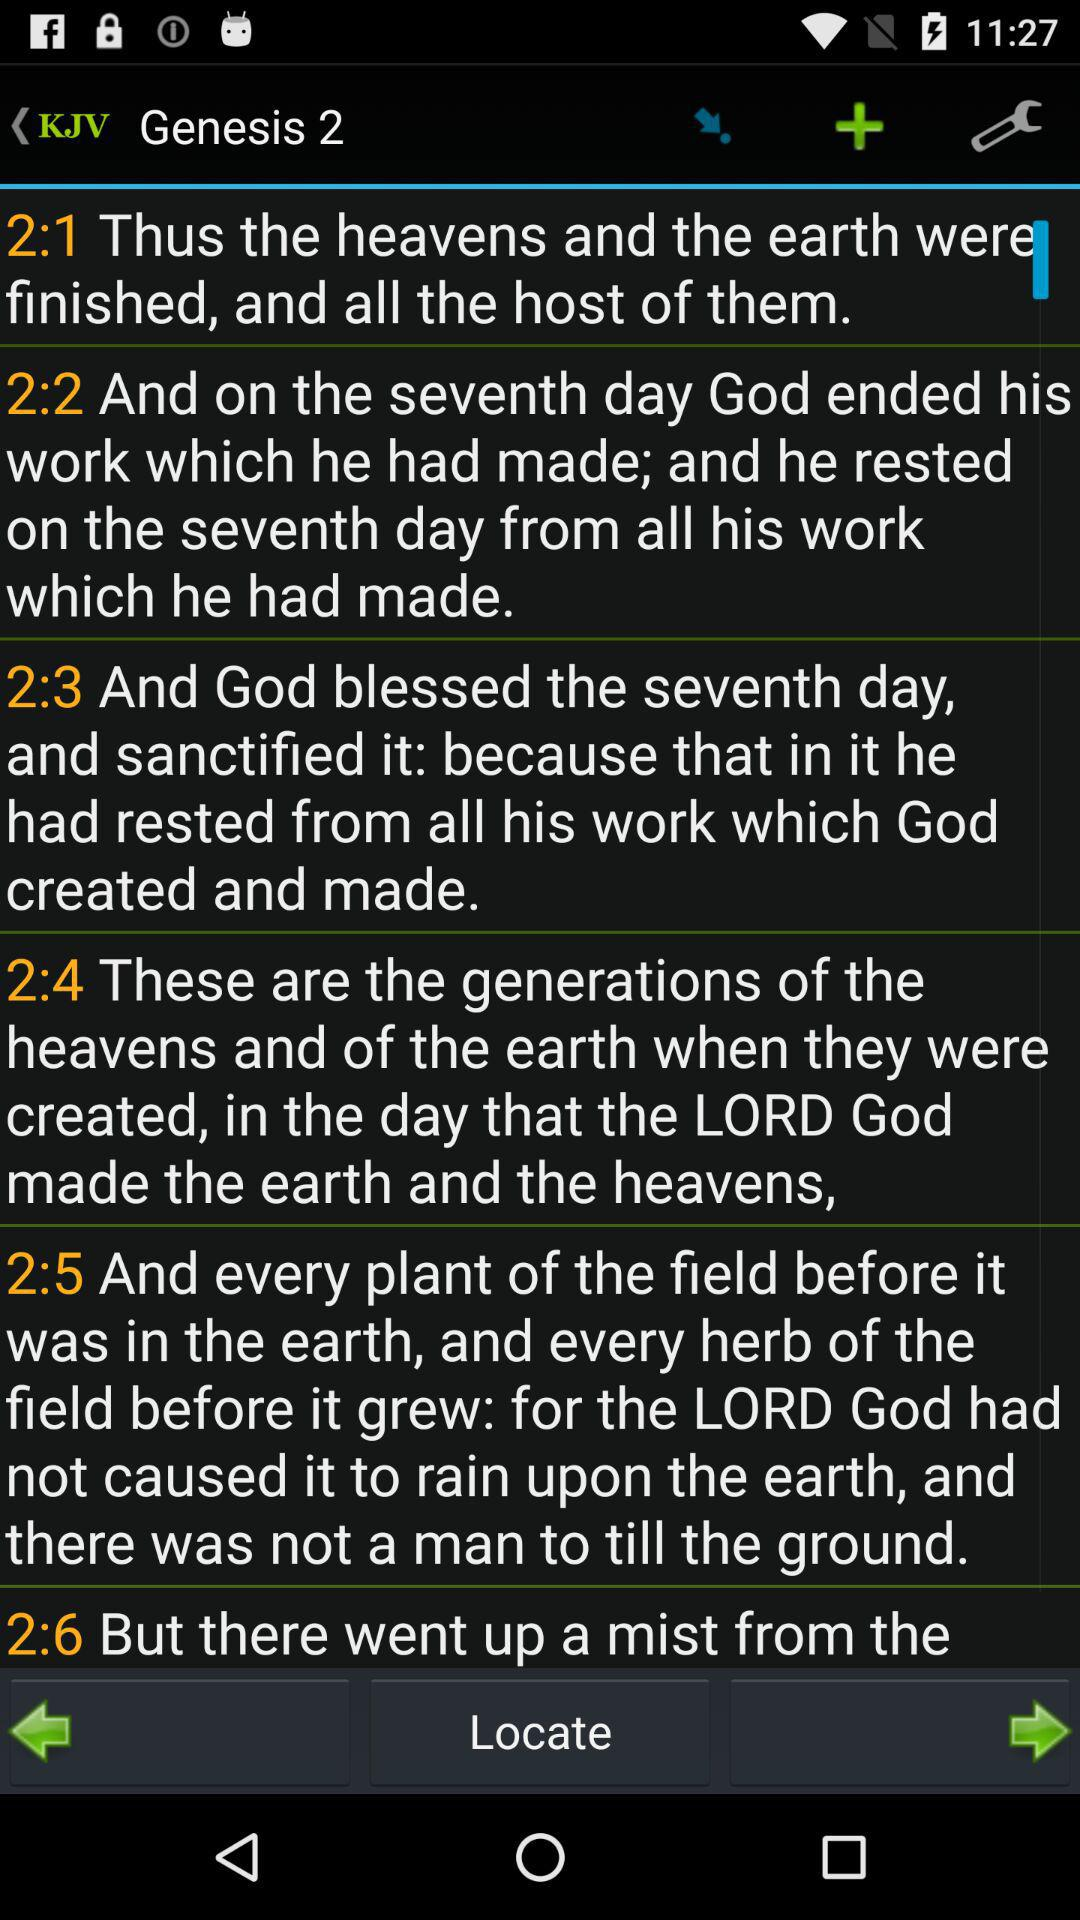Who rested on the seventh day from all his work? On the seventh day, God rested from all his work. 